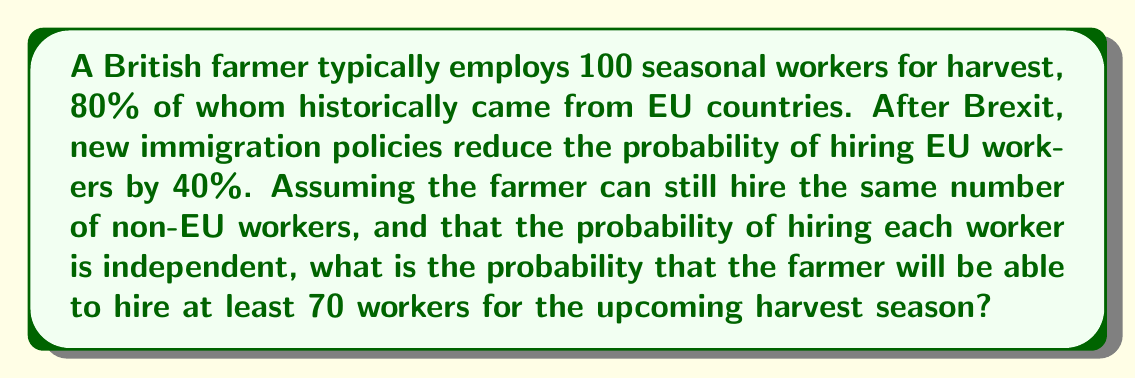What is the answer to this math problem? Let's approach this step-by-step:

1) Before Brexit:
   - 80 workers (80%) came from EU
   - 20 workers (20%) came from non-EU countries

2) After Brexit:
   - Probability of hiring EU workers reduced by 40%
   - New probability of hiring an EU worker = 60% of original
   - Expected number of EU workers = 80 * 0.6 = 48

3) Total expected workers:
   - 48 (EU) + 20 (non-EU) = 68 workers

4) We can model this as a binomial distribution:
   - n (total trials) = 100 (total positions)
   - p (probability of success) = 68/100 = 0.68
   - We want P(X ≥ 70), where X is the number of workers hired

5) Using the complement rule:
   P(X ≥ 70) = 1 - P(X < 70) = 1 - P(X ≤ 69)

6) The probability can be calculated using the cumulative binomial distribution function:

   $$P(X \geq 70) = 1 - \sum_{k=0}^{69} \binom{100}{k} (0.68)^k (0.32)^{100-k}$$

7) This can be computed using statistical software or calculators:

   P(X ≥ 70) ≈ 0.6354

Thus, there is approximately a 63.54% chance that the farmer will be able to hire at least 70 workers.
Answer: 0.6354 